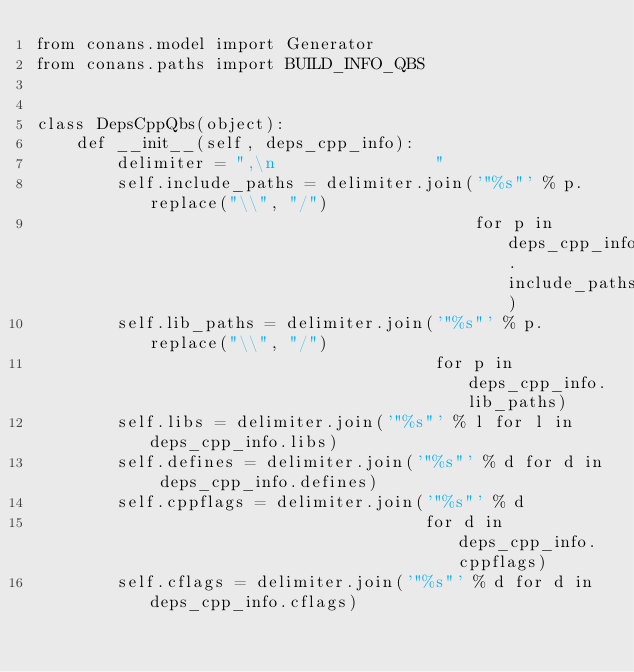<code> <loc_0><loc_0><loc_500><loc_500><_Python_>from conans.model import Generator
from conans.paths import BUILD_INFO_QBS


class DepsCppQbs(object):
    def __init__(self, deps_cpp_info):
        delimiter = ",\n                "
        self.include_paths = delimiter.join('"%s"' % p.replace("\\", "/")
                                            for p in deps_cpp_info.include_paths)
        self.lib_paths = delimiter.join('"%s"' % p.replace("\\", "/")
                                        for p in deps_cpp_info.lib_paths)
        self.libs = delimiter.join('"%s"' % l for l in deps_cpp_info.libs)
        self.defines = delimiter.join('"%s"' % d for d in deps_cpp_info.defines)
        self.cppflags = delimiter.join('"%s"' % d
                                       for d in deps_cpp_info.cppflags)
        self.cflags = delimiter.join('"%s"' % d for d in deps_cpp_info.cflags)</code> 